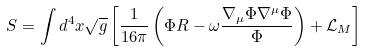Convert formula to latex. <formula><loc_0><loc_0><loc_500><loc_500>S = \int d ^ { 4 } x \sqrt { g } \left [ \frac { 1 } { 1 6 \pi } \left ( \Phi R - \omega \frac { \nabla _ { \mu } \Phi \nabla ^ { \mu } \Phi } { \Phi } \right ) + \mathcal { L } _ { M } \right ]</formula> 